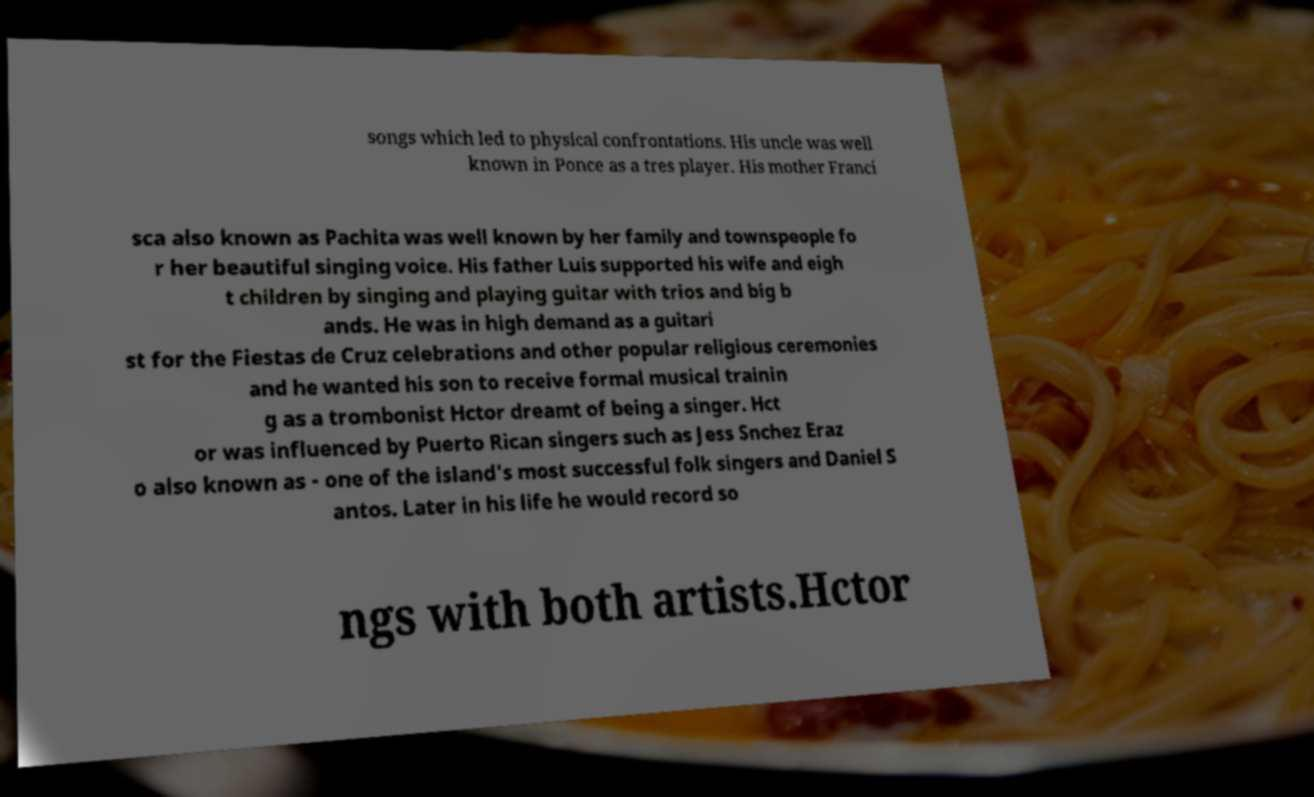Please identify and transcribe the text found in this image. songs which led to physical confrontations. His uncle was well known in Ponce as a tres player. His mother Franci sca also known as Pachita was well known by her family and townspeople fo r her beautiful singing voice. His father Luis supported his wife and eigh t children by singing and playing guitar with trios and big b ands. He was in high demand as a guitari st for the Fiestas de Cruz celebrations and other popular religious ceremonies and he wanted his son to receive formal musical trainin g as a trombonist Hctor dreamt of being a singer. Hct or was influenced by Puerto Rican singers such as Jess Snchez Eraz o also known as - one of the island's most successful folk singers and Daniel S antos. Later in his life he would record so ngs with both artists.Hctor 